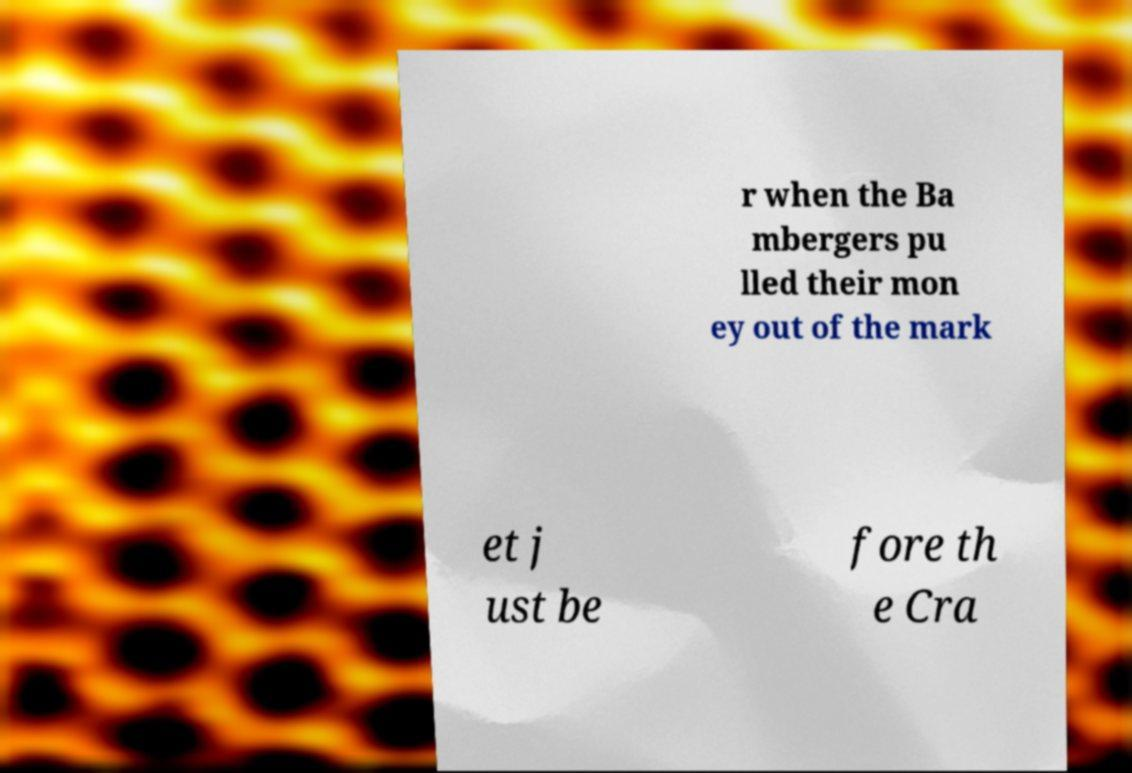Can you accurately transcribe the text from the provided image for me? r when the Ba mbergers pu lled their mon ey out of the mark et j ust be fore th e Cra 